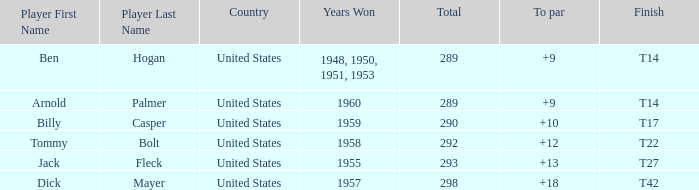What is Player, when Year(s) Won is 1955? Jack Fleck. 